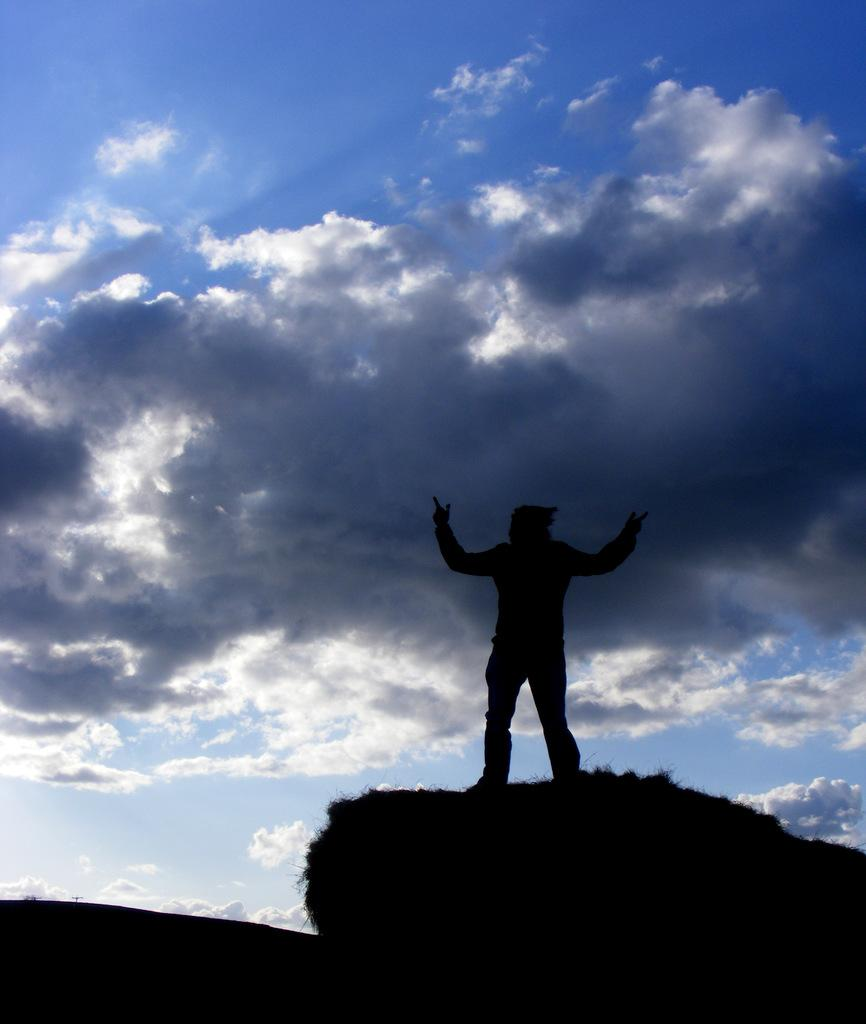What is the position of the person in the image? There is a person standing on the right side of the image. What is the condition of the sky in the image? The sky is blue and cloudy in the image. How many eggs are visible in the image? There are no eggs present in the image. What type of credit is the person holding in the image? There is no credit visible in the image; the person is simply standing on the right side. 